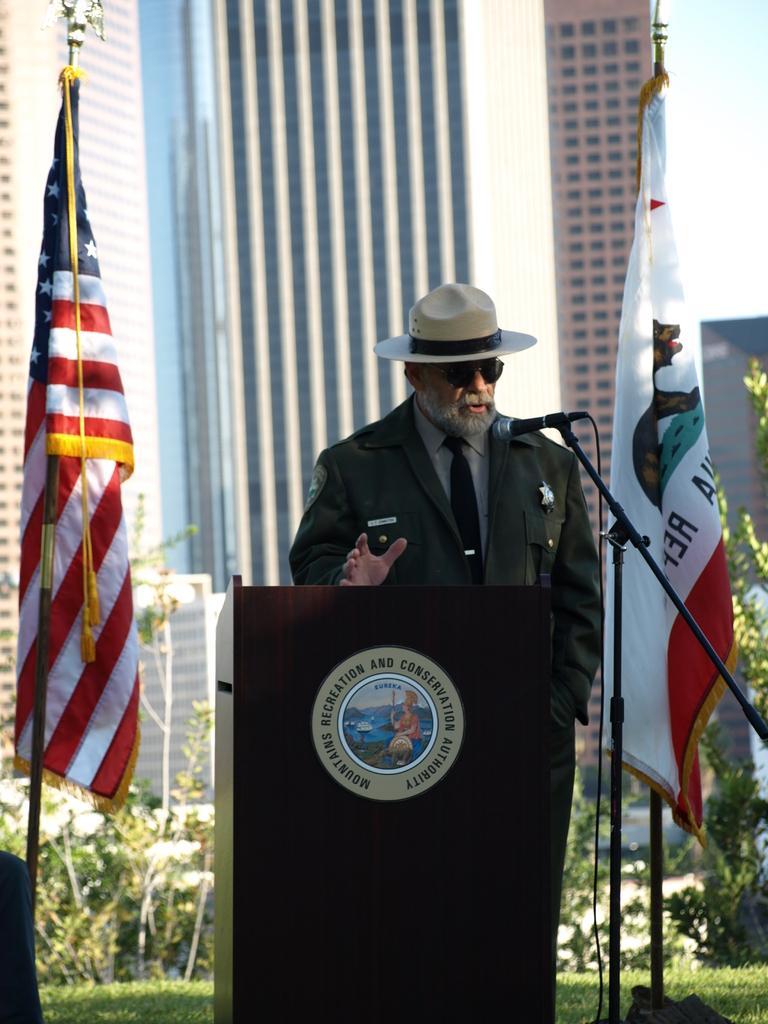Can you describe this image briefly? In this picture there is a person wearing hat is standing and there is a mic and a wooden stand in front of him and there are two flags,plants and buildings in the background. 